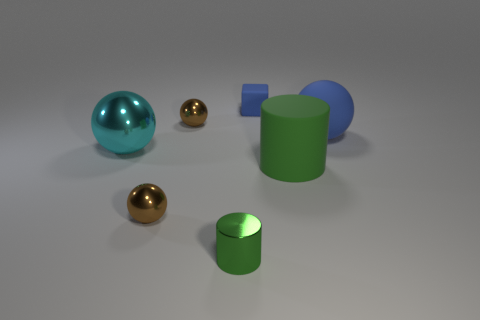Are there the same number of large blue spheres on the left side of the large rubber sphere and blue rubber blocks in front of the metallic cylinder?
Ensure brevity in your answer.  Yes. There is a big cyan shiny object; does it have the same shape as the green object that is on the right side of the tiny blue matte block?
Provide a succinct answer. No. How many other things are there of the same material as the big cylinder?
Your answer should be compact. 2. Are there any cyan things in front of the small cylinder?
Your answer should be compact. No. Is the size of the blue block the same as the brown object that is in front of the big cyan shiny ball?
Offer a terse response. Yes. What is the color of the tiny sphere in front of the large sphere right of the small rubber thing?
Provide a succinct answer. Brown. Is the blue rubber cube the same size as the green metallic cylinder?
Ensure brevity in your answer.  Yes. The tiny thing that is behind the big cyan thing and left of the small blue object is what color?
Offer a terse response. Brown. What size is the green metallic object?
Your answer should be compact. Small. Is the color of the big sphere to the right of the tiny cylinder the same as the large cylinder?
Keep it short and to the point. No. 